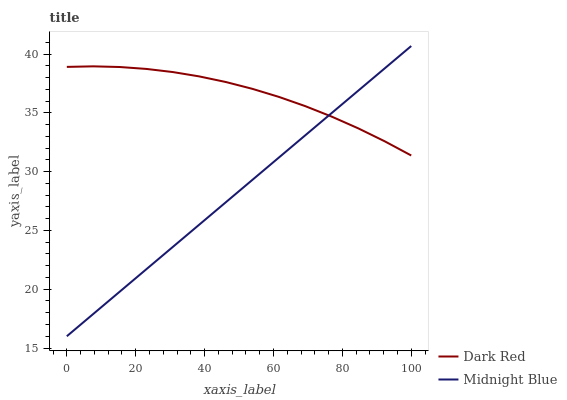Does Midnight Blue have the minimum area under the curve?
Answer yes or no. Yes. Does Dark Red have the maximum area under the curve?
Answer yes or no. Yes. Does Midnight Blue have the maximum area under the curve?
Answer yes or no. No. Is Midnight Blue the smoothest?
Answer yes or no. Yes. Is Dark Red the roughest?
Answer yes or no. Yes. Is Midnight Blue the roughest?
Answer yes or no. No. Does Midnight Blue have the lowest value?
Answer yes or no. Yes. Does Midnight Blue have the highest value?
Answer yes or no. Yes. Does Midnight Blue intersect Dark Red?
Answer yes or no. Yes. Is Midnight Blue less than Dark Red?
Answer yes or no. No. Is Midnight Blue greater than Dark Red?
Answer yes or no. No. 